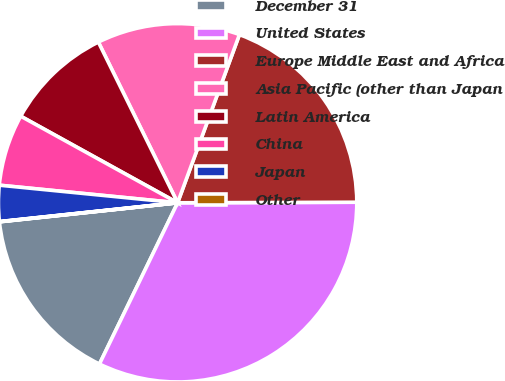Convert chart to OTSL. <chart><loc_0><loc_0><loc_500><loc_500><pie_chart><fcel>December 31<fcel>United States<fcel>Europe Middle East and Africa<fcel>Asia Pacific (other than Japan<fcel>Latin America<fcel>China<fcel>Japan<fcel>Other<nl><fcel>16.12%<fcel>32.23%<fcel>19.34%<fcel>12.9%<fcel>9.68%<fcel>6.46%<fcel>3.24%<fcel>0.02%<nl></chart> 